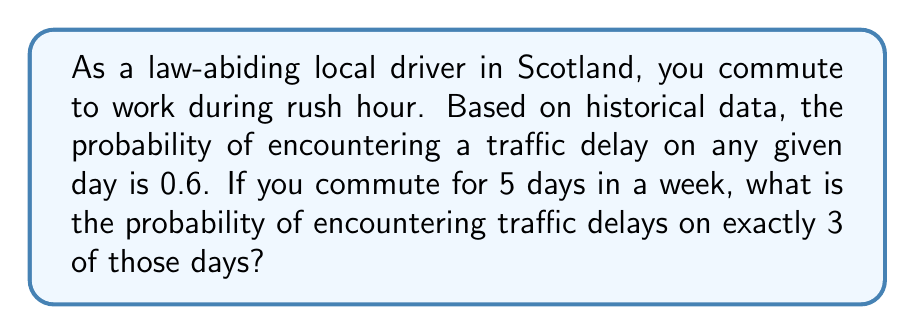Give your solution to this math problem. To solve this problem, we'll use the binomial probability distribution, as we have a fixed number of independent trials (5 days) with two possible outcomes for each trial (delay or no delay).

Let X be the random variable representing the number of days with traffic delays.

1) The probability mass function for a binomial distribution is:

   $$P(X = k) = \binom{n}{k} p^k (1-p)^{n-k}$$

   Where:
   n = number of trials
   k = number of successes
   p = probability of success on each trial

2) In this case:
   n = 5 (days)
   k = 3 (days with delays)
   p = 0.6 (probability of delay on any given day)

3) Substituting these values:

   $$P(X = 3) = \binom{5}{3} (0.6)^3 (1-0.6)^{5-3}$$

4) Calculate the binomial coefficient:

   $$\binom{5}{3} = \frac{5!}{3!(5-3)!} = \frac{5 \cdot 4}{2 \cdot 1} = 10$$

5) Now, let's compute the probability:

   $$P(X = 3) = 10 \cdot (0.6)^3 \cdot (0.4)^2$$

6) Simplify:

   $$P(X = 3) = 10 \cdot 0.216 \cdot 0.16 = 0.3456$$

Therefore, the probability of encountering traffic delays on exactly 3 out of 5 days is 0.3456 or about 34.56%.
Answer: 0.3456 